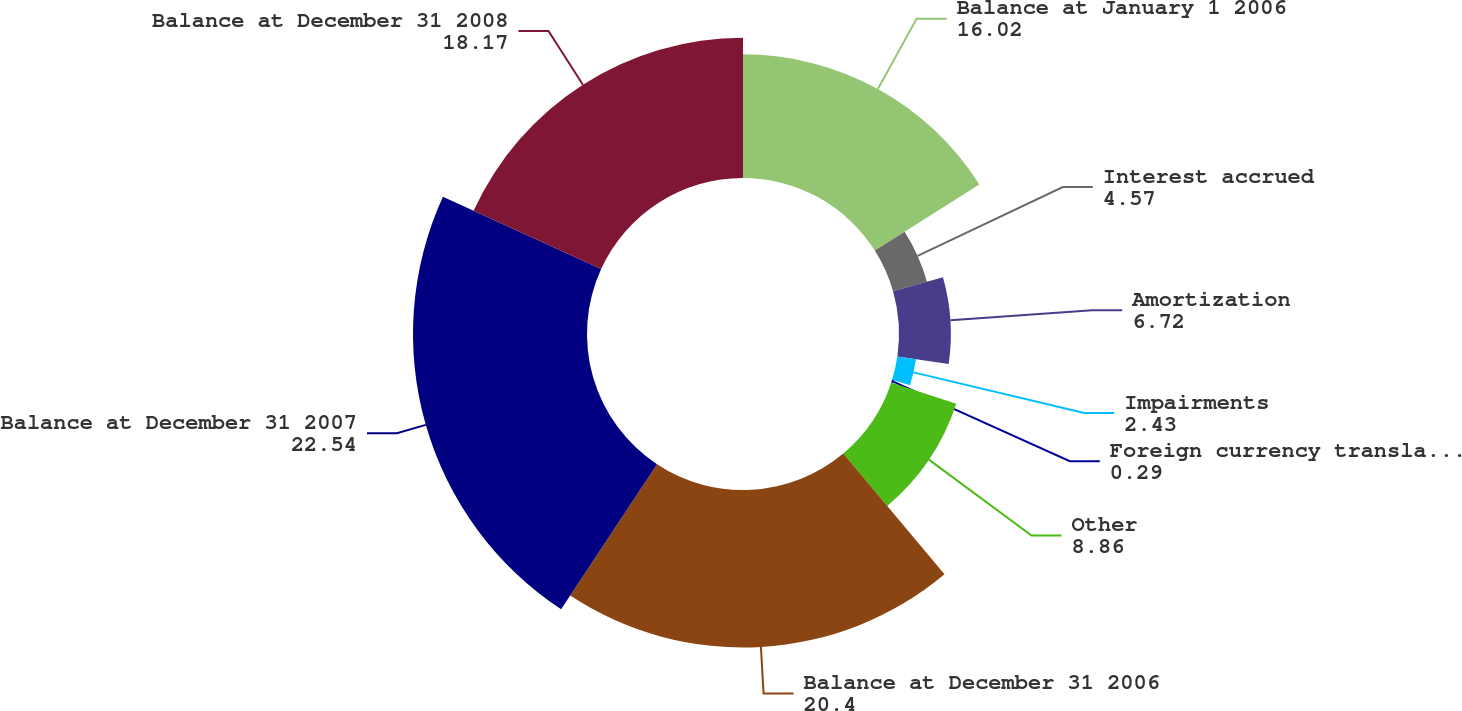Convert chart to OTSL. <chart><loc_0><loc_0><loc_500><loc_500><pie_chart><fcel>Balance at January 1 2006<fcel>Interest accrued<fcel>Amortization<fcel>Impairments<fcel>Foreign currency translation<fcel>Other<fcel>Balance at December 31 2006<fcel>Balance at December 31 2007<fcel>Balance at December 31 2008<nl><fcel>16.02%<fcel>4.57%<fcel>6.72%<fcel>2.43%<fcel>0.29%<fcel>8.86%<fcel>20.4%<fcel>22.54%<fcel>18.17%<nl></chart> 